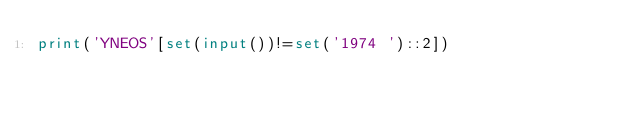<code> <loc_0><loc_0><loc_500><loc_500><_Python_>print('YNEOS'[set(input())!=set('1974 ')::2])</code> 